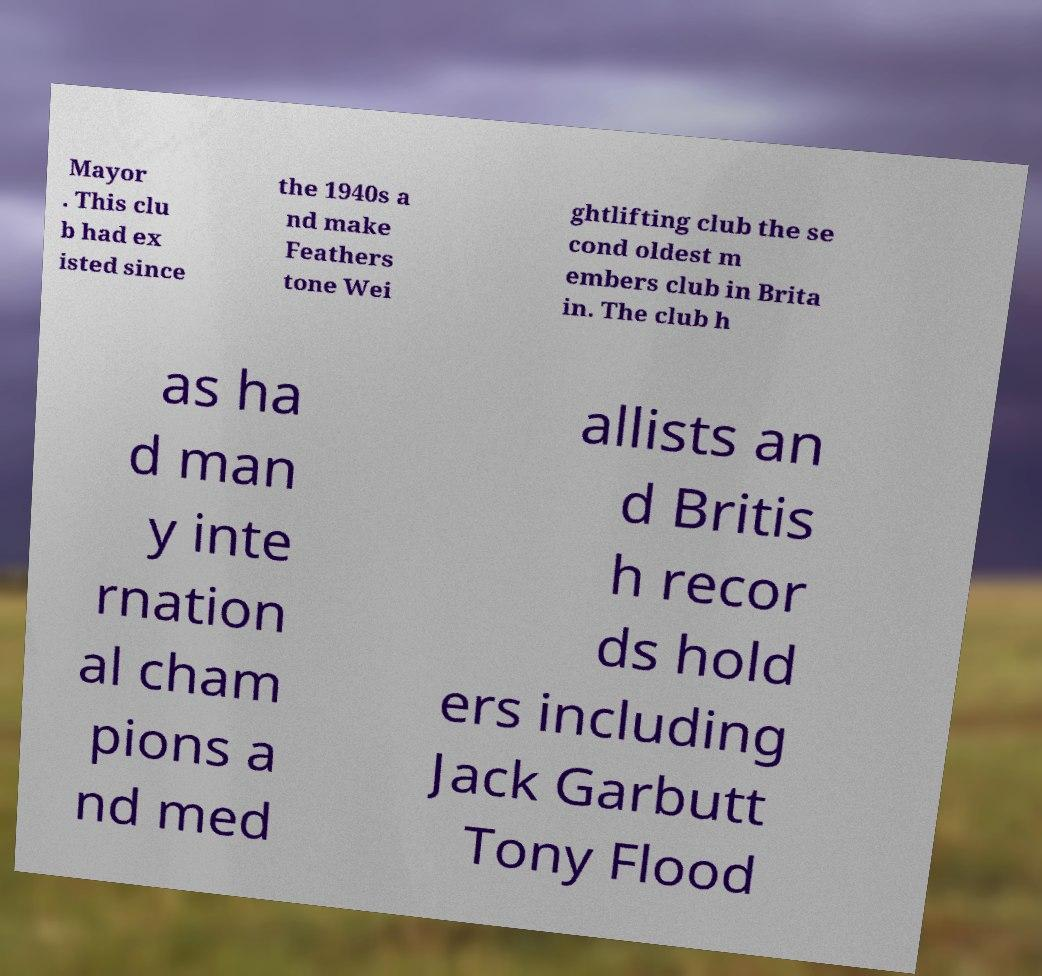What messages or text are displayed in this image? I need them in a readable, typed format. Mayor . This clu b had ex isted since the 1940s a nd make Feathers tone Wei ghtlifting club the se cond oldest m embers club in Brita in. The club h as ha d man y inte rnation al cham pions a nd med allists an d Britis h recor ds hold ers including Jack Garbutt Tony Flood 